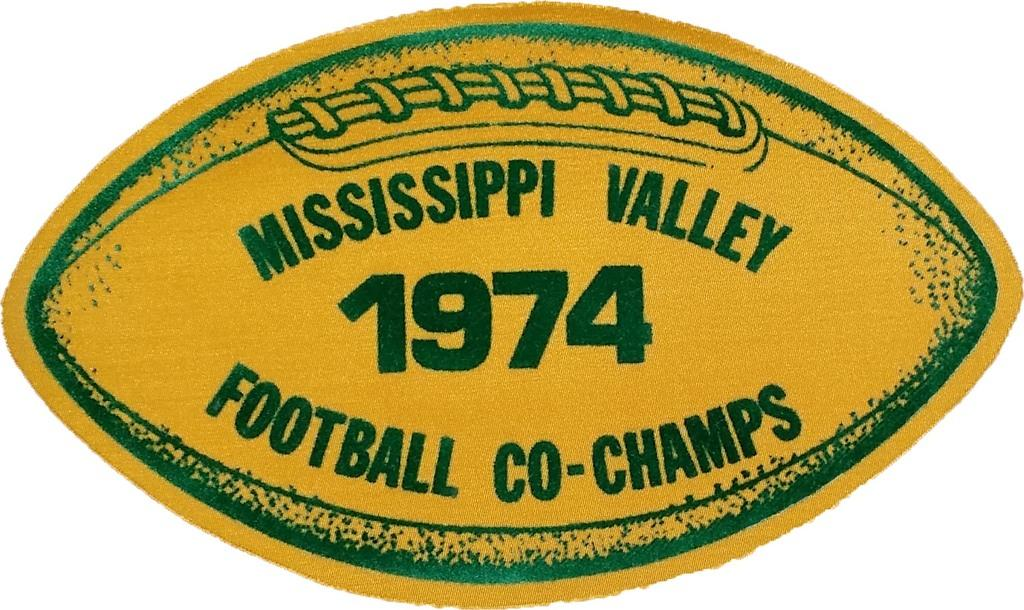What is featured on the poster in the image? There is a poster in the image, and it has an image of a ball. What else can be found on the poster besides the image? There is text on the poster. What sense is being evoked by the lake in the image? There is no lake present in the image; it only features a poster with an image of a ball and text. 